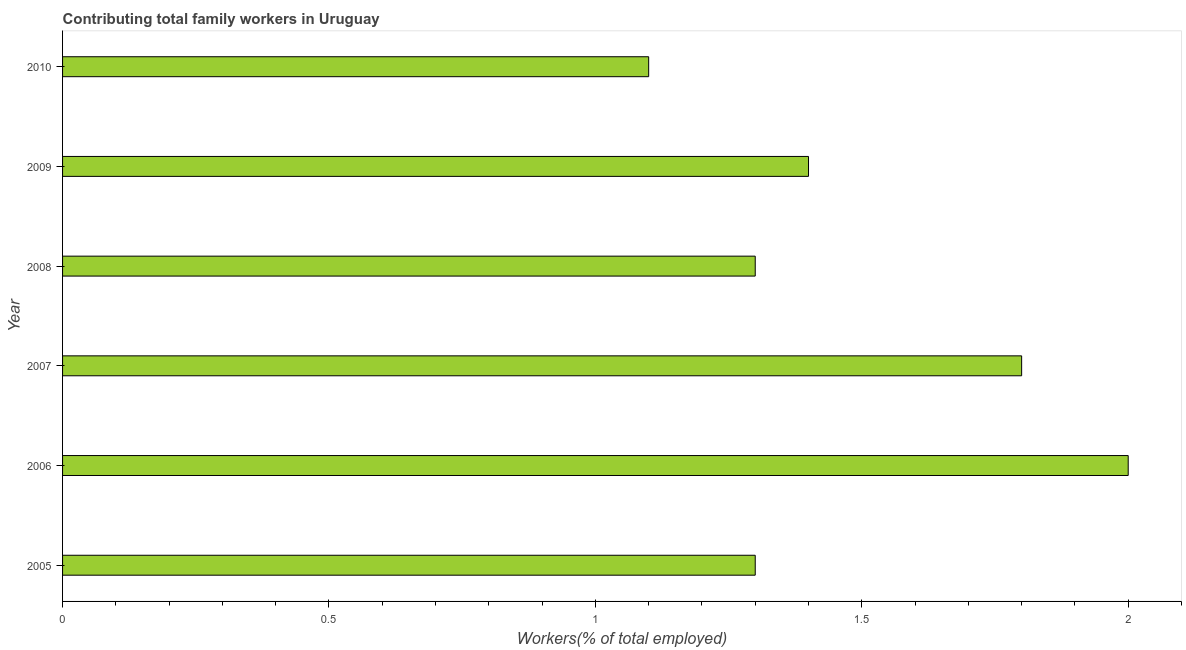What is the title of the graph?
Your answer should be compact. Contributing total family workers in Uruguay. What is the label or title of the X-axis?
Provide a succinct answer. Workers(% of total employed). What is the contributing family workers in 2007?
Your answer should be very brief. 1.8. Across all years, what is the minimum contributing family workers?
Give a very brief answer. 1.1. In which year was the contributing family workers maximum?
Give a very brief answer. 2006. What is the sum of the contributing family workers?
Provide a succinct answer. 8.9. What is the difference between the contributing family workers in 2006 and 2007?
Make the answer very short. 0.2. What is the average contributing family workers per year?
Ensure brevity in your answer.  1.48. What is the median contributing family workers?
Your answer should be compact. 1.35. Do a majority of the years between 2009 and 2006 (inclusive) have contributing family workers greater than 1 %?
Provide a succinct answer. Yes. What is the ratio of the contributing family workers in 2008 to that in 2009?
Offer a terse response. 0.93. What is the difference between the highest and the second highest contributing family workers?
Offer a terse response. 0.2. Is the sum of the contributing family workers in 2006 and 2007 greater than the maximum contributing family workers across all years?
Provide a succinct answer. Yes. What is the difference between the highest and the lowest contributing family workers?
Your answer should be compact. 0.9. In how many years, is the contributing family workers greater than the average contributing family workers taken over all years?
Ensure brevity in your answer.  2. What is the difference between two consecutive major ticks on the X-axis?
Provide a succinct answer. 0.5. What is the Workers(% of total employed) of 2005?
Keep it short and to the point. 1.3. What is the Workers(% of total employed) in 2006?
Provide a succinct answer. 2. What is the Workers(% of total employed) in 2007?
Make the answer very short. 1.8. What is the Workers(% of total employed) in 2008?
Provide a succinct answer. 1.3. What is the Workers(% of total employed) in 2009?
Offer a terse response. 1.4. What is the Workers(% of total employed) of 2010?
Provide a short and direct response. 1.1. What is the difference between the Workers(% of total employed) in 2005 and 2010?
Ensure brevity in your answer.  0.2. What is the difference between the Workers(% of total employed) in 2006 and 2007?
Keep it short and to the point. 0.2. What is the difference between the Workers(% of total employed) in 2006 and 2008?
Offer a very short reply. 0.7. What is the difference between the Workers(% of total employed) in 2006 and 2010?
Offer a very short reply. 0.9. What is the difference between the Workers(% of total employed) in 2007 and 2008?
Offer a terse response. 0.5. What is the difference between the Workers(% of total employed) in 2007 and 2010?
Keep it short and to the point. 0.7. What is the difference between the Workers(% of total employed) in 2008 and 2009?
Make the answer very short. -0.1. What is the difference between the Workers(% of total employed) in 2009 and 2010?
Offer a very short reply. 0.3. What is the ratio of the Workers(% of total employed) in 2005 to that in 2006?
Give a very brief answer. 0.65. What is the ratio of the Workers(% of total employed) in 2005 to that in 2007?
Provide a succinct answer. 0.72. What is the ratio of the Workers(% of total employed) in 2005 to that in 2009?
Offer a very short reply. 0.93. What is the ratio of the Workers(% of total employed) in 2005 to that in 2010?
Ensure brevity in your answer.  1.18. What is the ratio of the Workers(% of total employed) in 2006 to that in 2007?
Give a very brief answer. 1.11. What is the ratio of the Workers(% of total employed) in 2006 to that in 2008?
Keep it short and to the point. 1.54. What is the ratio of the Workers(% of total employed) in 2006 to that in 2009?
Ensure brevity in your answer.  1.43. What is the ratio of the Workers(% of total employed) in 2006 to that in 2010?
Your answer should be very brief. 1.82. What is the ratio of the Workers(% of total employed) in 2007 to that in 2008?
Offer a terse response. 1.39. What is the ratio of the Workers(% of total employed) in 2007 to that in 2009?
Offer a very short reply. 1.29. What is the ratio of the Workers(% of total employed) in 2007 to that in 2010?
Your response must be concise. 1.64. What is the ratio of the Workers(% of total employed) in 2008 to that in 2009?
Your response must be concise. 0.93. What is the ratio of the Workers(% of total employed) in 2008 to that in 2010?
Offer a terse response. 1.18. What is the ratio of the Workers(% of total employed) in 2009 to that in 2010?
Provide a short and direct response. 1.27. 